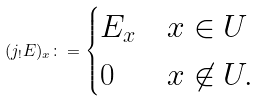Convert formula to latex. <formula><loc_0><loc_0><loc_500><loc_500>( j _ { ! } E ) _ { x } \colon = \begin{cases} E _ { x } & x \in U \\ 0 & x \not \in U . \end{cases}</formula> 